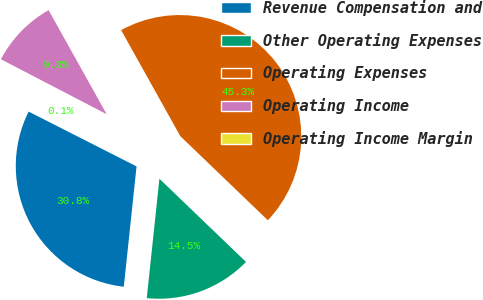Convert chart to OTSL. <chart><loc_0><loc_0><loc_500><loc_500><pie_chart><fcel>Revenue Compensation and<fcel>Other Operating Expenses<fcel>Operating Expenses<fcel>Operating Income<fcel>Operating Income Margin<nl><fcel>30.8%<fcel>14.5%<fcel>45.29%<fcel>9.27%<fcel>0.15%<nl></chart> 